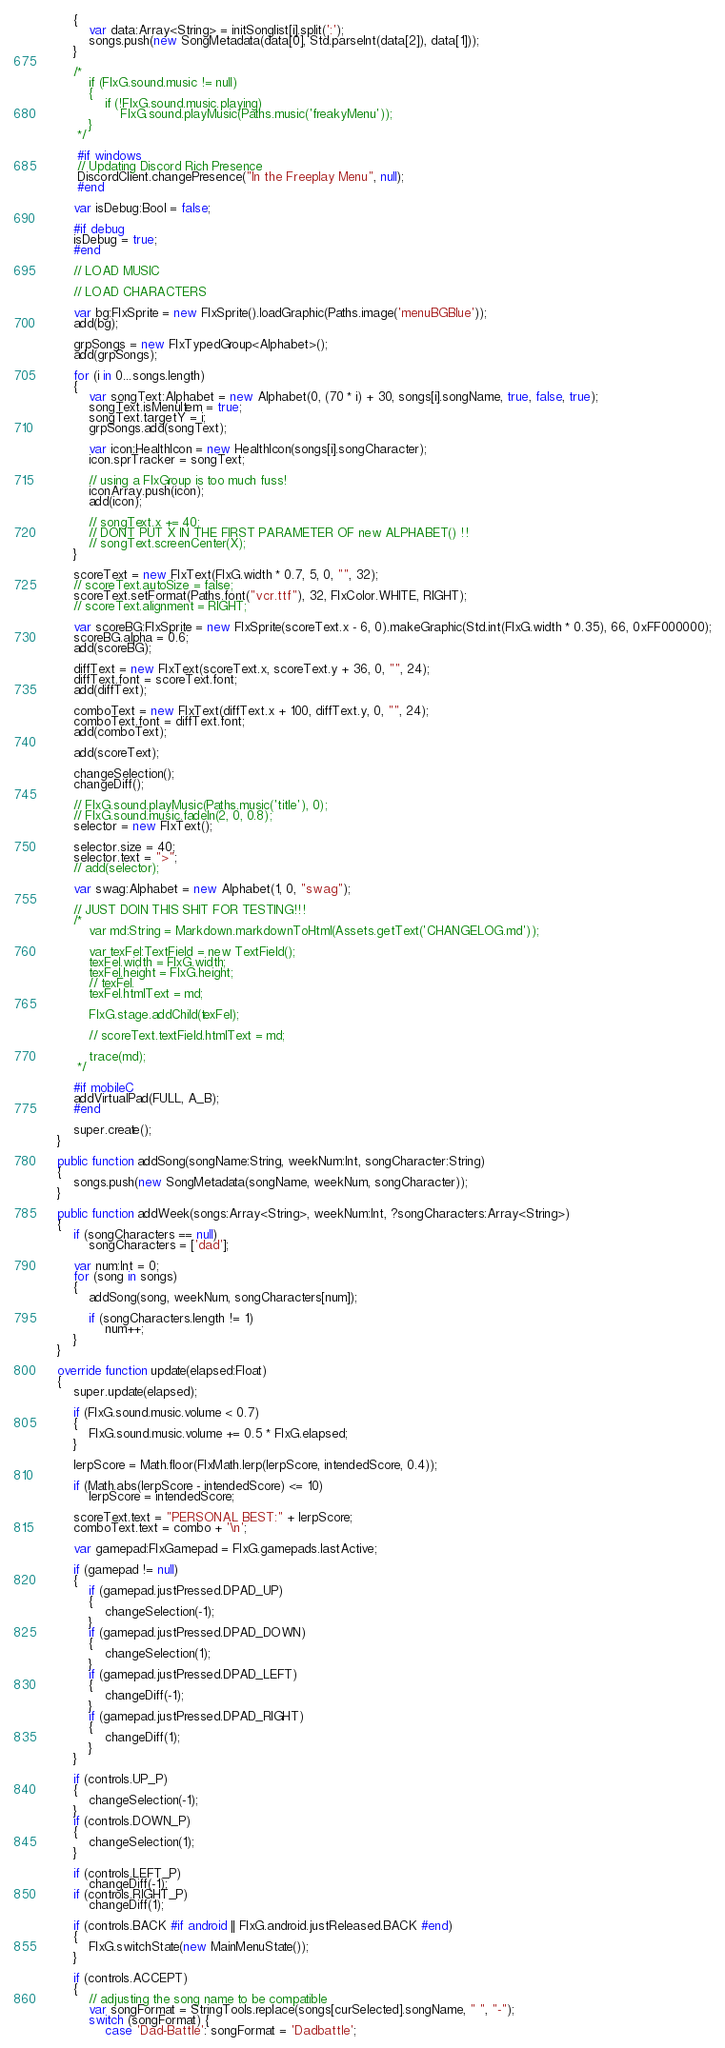Convert code to text. <code><loc_0><loc_0><loc_500><loc_500><_Haxe_>		{
			var data:Array<String> = initSonglist[i].split(':');
			songs.push(new SongMetadata(data[0], Std.parseInt(data[2]), data[1]));
		}

		/* 
			if (FlxG.sound.music != null)
			{
				if (!FlxG.sound.music.playing)
					FlxG.sound.playMusic(Paths.music('freakyMenu'));
			}
		 */

		 #if windows
		 // Updating Discord Rich Presence
		 DiscordClient.changePresence("In the Freeplay Menu", null);
		 #end

		var isDebug:Bool = false;

		#if debug
		isDebug = true;
		#end

		// LOAD MUSIC

		// LOAD CHARACTERS

		var bg:FlxSprite = new FlxSprite().loadGraphic(Paths.image('menuBGBlue'));
		add(bg);

		grpSongs = new FlxTypedGroup<Alphabet>();
		add(grpSongs);

		for (i in 0...songs.length)
		{
			var songText:Alphabet = new Alphabet(0, (70 * i) + 30, songs[i].songName, true, false, true);
			songText.isMenuItem = true;
			songText.targetY = i;
			grpSongs.add(songText);

			var icon:HealthIcon = new HealthIcon(songs[i].songCharacter);
			icon.sprTracker = songText;

			// using a FlxGroup is too much fuss!
			iconArray.push(icon);
			add(icon);

			// songText.x += 40;
			// DONT PUT X IN THE FIRST PARAMETER OF new ALPHABET() !!
			// songText.screenCenter(X);
		}

		scoreText = new FlxText(FlxG.width * 0.7, 5, 0, "", 32);
		// scoreText.autoSize = false;
		scoreText.setFormat(Paths.font("vcr.ttf"), 32, FlxColor.WHITE, RIGHT);
		// scoreText.alignment = RIGHT;

		var scoreBG:FlxSprite = new FlxSprite(scoreText.x - 6, 0).makeGraphic(Std.int(FlxG.width * 0.35), 66, 0xFF000000);
		scoreBG.alpha = 0.6;
		add(scoreBG);

		diffText = new FlxText(scoreText.x, scoreText.y + 36, 0, "", 24);
		diffText.font = scoreText.font;
		add(diffText);

		comboText = new FlxText(diffText.x + 100, diffText.y, 0, "", 24);
		comboText.font = diffText.font;
		add(comboText);

		add(scoreText);

		changeSelection();
		changeDiff();

		// FlxG.sound.playMusic(Paths.music('title'), 0);
		// FlxG.sound.music.fadeIn(2, 0, 0.8);
		selector = new FlxText();

		selector.size = 40;
		selector.text = ">";
		// add(selector);

		var swag:Alphabet = new Alphabet(1, 0, "swag");

		// JUST DOIN THIS SHIT FOR TESTING!!!
		/* 
			var md:String = Markdown.markdownToHtml(Assets.getText('CHANGELOG.md'));

			var texFel:TextField = new TextField();
			texFel.width = FlxG.width;
			texFel.height = FlxG.height;
			// texFel.
			texFel.htmlText = md;

			FlxG.stage.addChild(texFel);

			// scoreText.textField.htmlText = md;

			trace(md);
		 */

		#if mobileC
		addVirtualPad(FULL, A_B);
		#end

		super.create();
	}

	public function addSong(songName:String, weekNum:Int, songCharacter:String)
	{
		songs.push(new SongMetadata(songName, weekNum, songCharacter));
	}

	public function addWeek(songs:Array<String>, weekNum:Int, ?songCharacters:Array<String>)
	{
		if (songCharacters == null)
			songCharacters = ['dad'];

		var num:Int = 0;
		for (song in songs)
		{
			addSong(song, weekNum, songCharacters[num]);

			if (songCharacters.length != 1)
				num++;
		}
	}

	override function update(elapsed:Float)
	{
		super.update(elapsed);

		if (FlxG.sound.music.volume < 0.7)
		{
			FlxG.sound.music.volume += 0.5 * FlxG.elapsed;
		}

		lerpScore = Math.floor(FlxMath.lerp(lerpScore, intendedScore, 0.4));

		if (Math.abs(lerpScore - intendedScore) <= 10)
			lerpScore = intendedScore;

		scoreText.text = "PERSONAL BEST:" + lerpScore;
		comboText.text = combo + '\n';

		var gamepad:FlxGamepad = FlxG.gamepads.lastActive;

		if (gamepad != null)
		{
			if (gamepad.justPressed.DPAD_UP)
			{
				changeSelection(-1);
			}
			if (gamepad.justPressed.DPAD_DOWN)
			{
				changeSelection(1);
			}
			if (gamepad.justPressed.DPAD_LEFT)
			{
				changeDiff(-1);
			}
			if (gamepad.justPressed.DPAD_RIGHT)
			{
				changeDiff(1);
			}
		}

		if (controls.UP_P)
		{
			changeSelection(-1);
		}
		if (controls.DOWN_P)
		{
			changeSelection(1);
		}

		if (controls.LEFT_P)
			changeDiff(-1);
		if (controls.RIGHT_P)
			changeDiff(1);

		if (controls.BACK #if android || FlxG.android.justReleased.BACK #end)
		{
			FlxG.switchState(new MainMenuState());
		}

		if (controls.ACCEPT)
		{
			// adjusting the song name to be compatible
			var songFormat = StringTools.replace(songs[curSelected].songName, " ", "-");
			switch (songFormat) {
				case 'Dad-Battle': songFormat = 'Dadbattle';</code> 